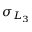<formula> <loc_0><loc_0><loc_500><loc_500>\sigma _ { L _ { 3 } }</formula> 